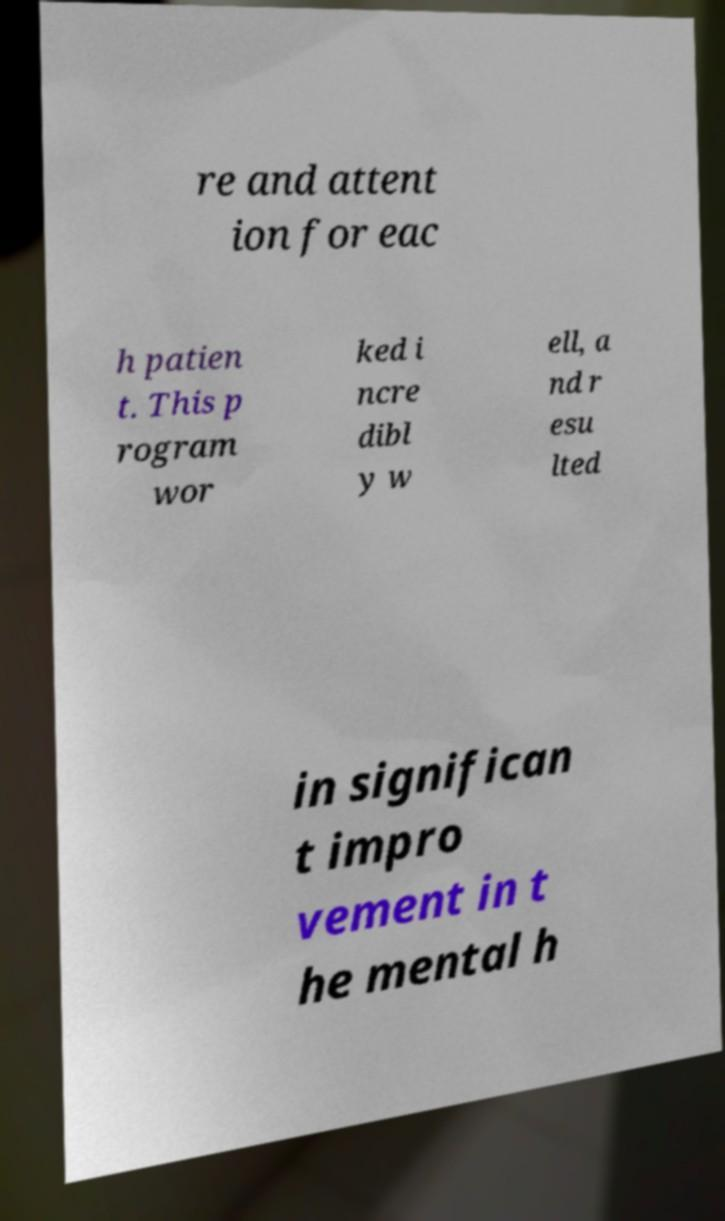I need the written content from this picture converted into text. Can you do that? re and attent ion for eac h patien t. This p rogram wor ked i ncre dibl y w ell, a nd r esu lted in significan t impro vement in t he mental h 